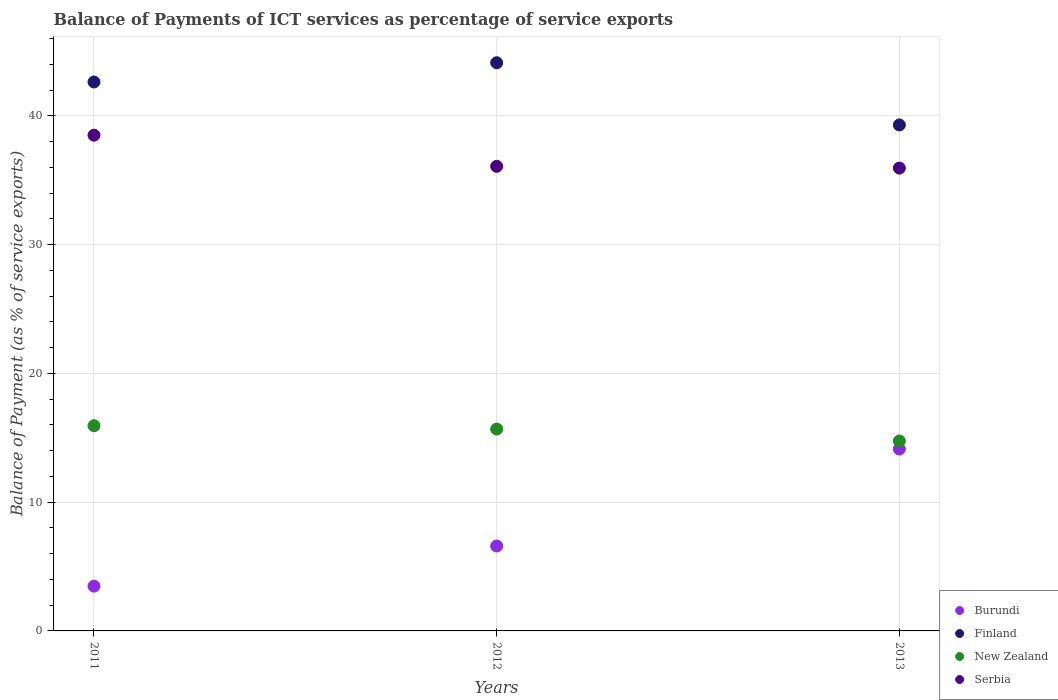What is the balance of payments of ICT services in Serbia in 2011?
Your answer should be compact. 38.5. Across all years, what is the maximum balance of payments of ICT services in Finland?
Offer a terse response. 44.12. Across all years, what is the minimum balance of payments of ICT services in Burundi?
Your response must be concise. 3.48. In which year was the balance of payments of ICT services in Finland minimum?
Provide a succinct answer. 2013. What is the total balance of payments of ICT services in Finland in the graph?
Your answer should be very brief. 126.05. What is the difference between the balance of payments of ICT services in Finland in 2012 and that in 2013?
Keep it short and to the point. 4.83. What is the difference between the balance of payments of ICT services in Burundi in 2011 and the balance of payments of ICT services in Serbia in 2013?
Offer a very short reply. -32.47. What is the average balance of payments of ICT services in New Zealand per year?
Give a very brief answer. 15.45. In the year 2013, what is the difference between the balance of payments of ICT services in Finland and balance of payments of ICT services in Burundi?
Your answer should be very brief. 25.17. What is the ratio of the balance of payments of ICT services in Finland in 2011 to that in 2013?
Ensure brevity in your answer.  1.08. Is the balance of payments of ICT services in Burundi in 2011 less than that in 2013?
Keep it short and to the point. Yes. What is the difference between the highest and the second highest balance of payments of ICT services in Burundi?
Provide a succinct answer. 7.53. What is the difference between the highest and the lowest balance of payments of ICT services in Burundi?
Provide a short and direct response. 10.65. Is it the case that in every year, the sum of the balance of payments of ICT services in Serbia and balance of payments of ICT services in Burundi  is greater than the sum of balance of payments of ICT services in New Zealand and balance of payments of ICT services in Finland?
Your response must be concise. Yes. Is it the case that in every year, the sum of the balance of payments of ICT services in New Zealand and balance of payments of ICT services in Finland  is greater than the balance of payments of ICT services in Burundi?
Offer a very short reply. Yes. Is the balance of payments of ICT services in Serbia strictly less than the balance of payments of ICT services in Burundi over the years?
Provide a short and direct response. No. How many dotlines are there?
Your answer should be very brief. 4. How many years are there in the graph?
Offer a terse response. 3. What is the difference between two consecutive major ticks on the Y-axis?
Your response must be concise. 10. Are the values on the major ticks of Y-axis written in scientific E-notation?
Offer a terse response. No. How many legend labels are there?
Your answer should be very brief. 4. How are the legend labels stacked?
Your answer should be compact. Vertical. What is the title of the graph?
Offer a terse response. Balance of Payments of ICT services as percentage of service exports. What is the label or title of the Y-axis?
Provide a short and direct response. Balance of Payment (as % of service exports). What is the Balance of Payment (as % of service exports) of Burundi in 2011?
Your answer should be compact. 3.48. What is the Balance of Payment (as % of service exports) of Finland in 2011?
Make the answer very short. 42.63. What is the Balance of Payment (as % of service exports) in New Zealand in 2011?
Give a very brief answer. 15.94. What is the Balance of Payment (as % of service exports) of Serbia in 2011?
Your answer should be very brief. 38.5. What is the Balance of Payment (as % of service exports) in Burundi in 2012?
Ensure brevity in your answer.  6.59. What is the Balance of Payment (as % of service exports) in Finland in 2012?
Keep it short and to the point. 44.12. What is the Balance of Payment (as % of service exports) in New Zealand in 2012?
Offer a terse response. 15.68. What is the Balance of Payment (as % of service exports) in Serbia in 2012?
Your response must be concise. 36.08. What is the Balance of Payment (as % of service exports) in Burundi in 2013?
Keep it short and to the point. 14.13. What is the Balance of Payment (as % of service exports) of Finland in 2013?
Your answer should be compact. 39.29. What is the Balance of Payment (as % of service exports) of New Zealand in 2013?
Keep it short and to the point. 14.75. What is the Balance of Payment (as % of service exports) of Serbia in 2013?
Offer a very short reply. 35.94. Across all years, what is the maximum Balance of Payment (as % of service exports) of Burundi?
Your response must be concise. 14.13. Across all years, what is the maximum Balance of Payment (as % of service exports) of Finland?
Ensure brevity in your answer.  44.12. Across all years, what is the maximum Balance of Payment (as % of service exports) of New Zealand?
Your answer should be very brief. 15.94. Across all years, what is the maximum Balance of Payment (as % of service exports) in Serbia?
Provide a short and direct response. 38.5. Across all years, what is the minimum Balance of Payment (as % of service exports) of Burundi?
Make the answer very short. 3.48. Across all years, what is the minimum Balance of Payment (as % of service exports) of Finland?
Keep it short and to the point. 39.29. Across all years, what is the minimum Balance of Payment (as % of service exports) of New Zealand?
Offer a terse response. 14.75. Across all years, what is the minimum Balance of Payment (as % of service exports) in Serbia?
Keep it short and to the point. 35.94. What is the total Balance of Payment (as % of service exports) in Burundi in the graph?
Offer a very short reply. 24.2. What is the total Balance of Payment (as % of service exports) in Finland in the graph?
Your answer should be very brief. 126.05. What is the total Balance of Payment (as % of service exports) in New Zealand in the graph?
Keep it short and to the point. 46.36. What is the total Balance of Payment (as % of service exports) in Serbia in the graph?
Offer a terse response. 110.52. What is the difference between the Balance of Payment (as % of service exports) in Burundi in 2011 and that in 2012?
Your answer should be very brief. -3.12. What is the difference between the Balance of Payment (as % of service exports) of Finland in 2011 and that in 2012?
Keep it short and to the point. -1.49. What is the difference between the Balance of Payment (as % of service exports) of New Zealand in 2011 and that in 2012?
Give a very brief answer. 0.26. What is the difference between the Balance of Payment (as % of service exports) in Serbia in 2011 and that in 2012?
Make the answer very short. 2.42. What is the difference between the Balance of Payment (as % of service exports) in Burundi in 2011 and that in 2013?
Offer a very short reply. -10.65. What is the difference between the Balance of Payment (as % of service exports) in Finland in 2011 and that in 2013?
Your response must be concise. 3.34. What is the difference between the Balance of Payment (as % of service exports) of New Zealand in 2011 and that in 2013?
Make the answer very short. 1.19. What is the difference between the Balance of Payment (as % of service exports) of Serbia in 2011 and that in 2013?
Your answer should be very brief. 2.56. What is the difference between the Balance of Payment (as % of service exports) of Burundi in 2012 and that in 2013?
Make the answer very short. -7.53. What is the difference between the Balance of Payment (as % of service exports) in Finland in 2012 and that in 2013?
Your response must be concise. 4.83. What is the difference between the Balance of Payment (as % of service exports) of New Zealand in 2012 and that in 2013?
Ensure brevity in your answer.  0.93. What is the difference between the Balance of Payment (as % of service exports) in Serbia in 2012 and that in 2013?
Your answer should be very brief. 0.14. What is the difference between the Balance of Payment (as % of service exports) of Burundi in 2011 and the Balance of Payment (as % of service exports) of Finland in 2012?
Offer a terse response. -40.65. What is the difference between the Balance of Payment (as % of service exports) of Burundi in 2011 and the Balance of Payment (as % of service exports) of New Zealand in 2012?
Provide a short and direct response. -12.2. What is the difference between the Balance of Payment (as % of service exports) of Burundi in 2011 and the Balance of Payment (as % of service exports) of Serbia in 2012?
Ensure brevity in your answer.  -32.6. What is the difference between the Balance of Payment (as % of service exports) in Finland in 2011 and the Balance of Payment (as % of service exports) in New Zealand in 2012?
Provide a succinct answer. 26.95. What is the difference between the Balance of Payment (as % of service exports) of Finland in 2011 and the Balance of Payment (as % of service exports) of Serbia in 2012?
Provide a succinct answer. 6.55. What is the difference between the Balance of Payment (as % of service exports) of New Zealand in 2011 and the Balance of Payment (as % of service exports) of Serbia in 2012?
Your answer should be compact. -20.14. What is the difference between the Balance of Payment (as % of service exports) of Burundi in 2011 and the Balance of Payment (as % of service exports) of Finland in 2013?
Your response must be concise. -35.82. What is the difference between the Balance of Payment (as % of service exports) in Burundi in 2011 and the Balance of Payment (as % of service exports) in New Zealand in 2013?
Offer a terse response. -11.27. What is the difference between the Balance of Payment (as % of service exports) of Burundi in 2011 and the Balance of Payment (as % of service exports) of Serbia in 2013?
Your answer should be very brief. -32.47. What is the difference between the Balance of Payment (as % of service exports) in Finland in 2011 and the Balance of Payment (as % of service exports) in New Zealand in 2013?
Offer a very short reply. 27.88. What is the difference between the Balance of Payment (as % of service exports) in Finland in 2011 and the Balance of Payment (as % of service exports) in Serbia in 2013?
Give a very brief answer. 6.69. What is the difference between the Balance of Payment (as % of service exports) in New Zealand in 2011 and the Balance of Payment (as % of service exports) in Serbia in 2013?
Provide a short and direct response. -20.01. What is the difference between the Balance of Payment (as % of service exports) in Burundi in 2012 and the Balance of Payment (as % of service exports) in Finland in 2013?
Provide a succinct answer. -32.7. What is the difference between the Balance of Payment (as % of service exports) of Burundi in 2012 and the Balance of Payment (as % of service exports) of New Zealand in 2013?
Your answer should be compact. -8.16. What is the difference between the Balance of Payment (as % of service exports) in Burundi in 2012 and the Balance of Payment (as % of service exports) in Serbia in 2013?
Provide a short and direct response. -29.35. What is the difference between the Balance of Payment (as % of service exports) in Finland in 2012 and the Balance of Payment (as % of service exports) in New Zealand in 2013?
Keep it short and to the point. 29.37. What is the difference between the Balance of Payment (as % of service exports) of Finland in 2012 and the Balance of Payment (as % of service exports) of Serbia in 2013?
Keep it short and to the point. 8.18. What is the difference between the Balance of Payment (as % of service exports) in New Zealand in 2012 and the Balance of Payment (as % of service exports) in Serbia in 2013?
Your response must be concise. -20.27. What is the average Balance of Payment (as % of service exports) of Burundi per year?
Your answer should be very brief. 8.07. What is the average Balance of Payment (as % of service exports) of Finland per year?
Ensure brevity in your answer.  42.02. What is the average Balance of Payment (as % of service exports) in New Zealand per year?
Your response must be concise. 15.45. What is the average Balance of Payment (as % of service exports) in Serbia per year?
Your answer should be very brief. 36.84. In the year 2011, what is the difference between the Balance of Payment (as % of service exports) in Burundi and Balance of Payment (as % of service exports) in Finland?
Provide a short and direct response. -39.15. In the year 2011, what is the difference between the Balance of Payment (as % of service exports) of Burundi and Balance of Payment (as % of service exports) of New Zealand?
Your answer should be very brief. -12.46. In the year 2011, what is the difference between the Balance of Payment (as % of service exports) of Burundi and Balance of Payment (as % of service exports) of Serbia?
Your response must be concise. -35.02. In the year 2011, what is the difference between the Balance of Payment (as % of service exports) of Finland and Balance of Payment (as % of service exports) of New Zealand?
Your answer should be compact. 26.69. In the year 2011, what is the difference between the Balance of Payment (as % of service exports) in Finland and Balance of Payment (as % of service exports) in Serbia?
Give a very brief answer. 4.13. In the year 2011, what is the difference between the Balance of Payment (as % of service exports) of New Zealand and Balance of Payment (as % of service exports) of Serbia?
Your answer should be very brief. -22.56. In the year 2012, what is the difference between the Balance of Payment (as % of service exports) in Burundi and Balance of Payment (as % of service exports) in Finland?
Offer a very short reply. -37.53. In the year 2012, what is the difference between the Balance of Payment (as % of service exports) in Burundi and Balance of Payment (as % of service exports) in New Zealand?
Offer a terse response. -9.08. In the year 2012, what is the difference between the Balance of Payment (as % of service exports) in Burundi and Balance of Payment (as % of service exports) in Serbia?
Provide a short and direct response. -29.49. In the year 2012, what is the difference between the Balance of Payment (as % of service exports) in Finland and Balance of Payment (as % of service exports) in New Zealand?
Your response must be concise. 28.45. In the year 2012, what is the difference between the Balance of Payment (as % of service exports) of Finland and Balance of Payment (as % of service exports) of Serbia?
Keep it short and to the point. 8.04. In the year 2012, what is the difference between the Balance of Payment (as % of service exports) in New Zealand and Balance of Payment (as % of service exports) in Serbia?
Give a very brief answer. -20.4. In the year 2013, what is the difference between the Balance of Payment (as % of service exports) in Burundi and Balance of Payment (as % of service exports) in Finland?
Your response must be concise. -25.17. In the year 2013, what is the difference between the Balance of Payment (as % of service exports) in Burundi and Balance of Payment (as % of service exports) in New Zealand?
Your answer should be very brief. -0.62. In the year 2013, what is the difference between the Balance of Payment (as % of service exports) of Burundi and Balance of Payment (as % of service exports) of Serbia?
Keep it short and to the point. -21.82. In the year 2013, what is the difference between the Balance of Payment (as % of service exports) in Finland and Balance of Payment (as % of service exports) in New Zealand?
Your answer should be very brief. 24.54. In the year 2013, what is the difference between the Balance of Payment (as % of service exports) of Finland and Balance of Payment (as % of service exports) of Serbia?
Offer a terse response. 3.35. In the year 2013, what is the difference between the Balance of Payment (as % of service exports) in New Zealand and Balance of Payment (as % of service exports) in Serbia?
Give a very brief answer. -21.19. What is the ratio of the Balance of Payment (as % of service exports) of Burundi in 2011 to that in 2012?
Provide a succinct answer. 0.53. What is the ratio of the Balance of Payment (as % of service exports) in Finland in 2011 to that in 2012?
Make the answer very short. 0.97. What is the ratio of the Balance of Payment (as % of service exports) in New Zealand in 2011 to that in 2012?
Offer a terse response. 1.02. What is the ratio of the Balance of Payment (as % of service exports) of Serbia in 2011 to that in 2012?
Your answer should be very brief. 1.07. What is the ratio of the Balance of Payment (as % of service exports) of Burundi in 2011 to that in 2013?
Your answer should be very brief. 0.25. What is the ratio of the Balance of Payment (as % of service exports) in Finland in 2011 to that in 2013?
Provide a short and direct response. 1.08. What is the ratio of the Balance of Payment (as % of service exports) of New Zealand in 2011 to that in 2013?
Provide a short and direct response. 1.08. What is the ratio of the Balance of Payment (as % of service exports) of Serbia in 2011 to that in 2013?
Make the answer very short. 1.07. What is the ratio of the Balance of Payment (as % of service exports) of Burundi in 2012 to that in 2013?
Your answer should be very brief. 0.47. What is the ratio of the Balance of Payment (as % of service exports) in Finland in 2012 to that in 2013?
Keep it short and to the point. 1.12. What is the ratio of the Balance of Payment (as % of service exports) in New Zealand in 2012 to that in 2013?
Give a very brief answer. 1.06. What is the difference between the highest and the second highest Balance of Payment (as % of service exports) of Burundi?
Offer a very short reply. 7.53. What is the difference between the highest and the second highest Balance of Payment (as % of service exports) of Finland?
Offer a very short reply. 1.49. What is the difference between the highest and the second highest Balance of Payment (as % of service exports) in New Zealand?
Your answer should be very brief. 0.26. What is the difference between the highest and the second highest Balance of Payment (as % of service exports) of Serbia?
Your response must be concise. 2.42. What is the difference between the highest and the lowest Balance of Payment (as % of service exports) in Burundi?
Your response must be concise. 10.65. What is the difference between the highest and the lowest Balance of Payment (as % of service exports) in Finland?
Provide a short and direct response. 4.83. What is the difference between the highest and the lowest Balance of Payment (as % of service exports) in New Zealand?
Your answer should be compact. 1.19. What is the difference between the highest and the lowest Balance of Payment (as % of service exports) in Serbia?
Make the answer very short. 2.56. 